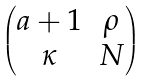Convert formula to latex. <formula><loc_0><loc_0><loc_500><loc_500>\begin{pmatrix} a + 1 & \rho \\ \kappa & N \end{pmatrix}</formula> 